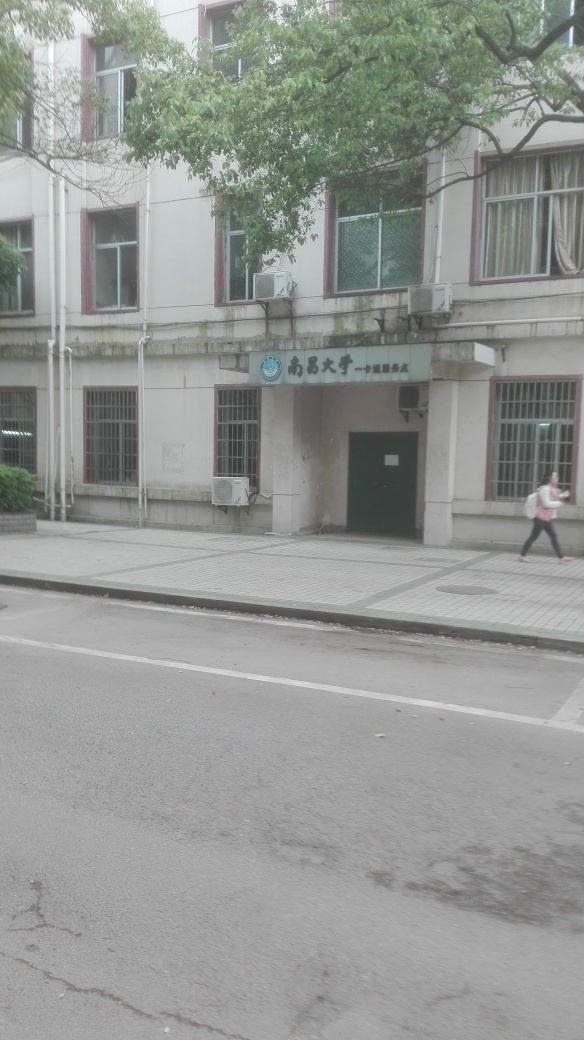What does the sign on the building say? The text on the sign is not entirely clear due to the resolution of the image. It appears to be in a non-Latin script, possibly Chinese, given the character shapes and general aesthetic. It likely identifies the name or function of the building. 